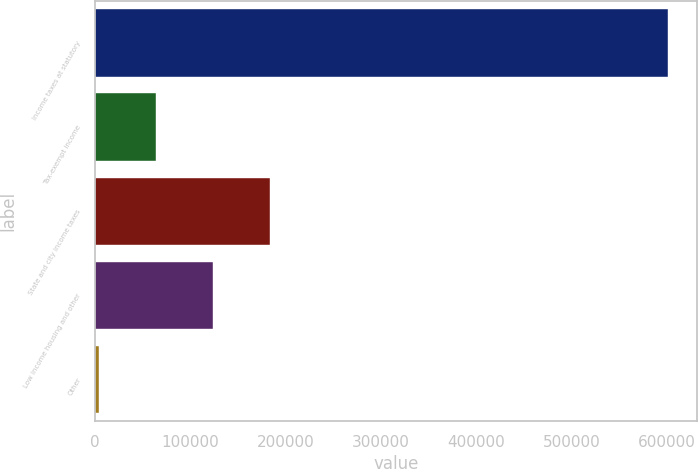Convert chart. <chart><loc_0><loc_0><loc_500><loc_500><bar_chart><fcel>Income taxes at statutory<fcel>Tax-exempt income<fcel>State and city income taxes<fcel>Low income housing and other<fcel>Other<nl><fcel>601142<fcel>63672.8<fcel>183110<fcel>123392<fcel>3954<nl></chart> 